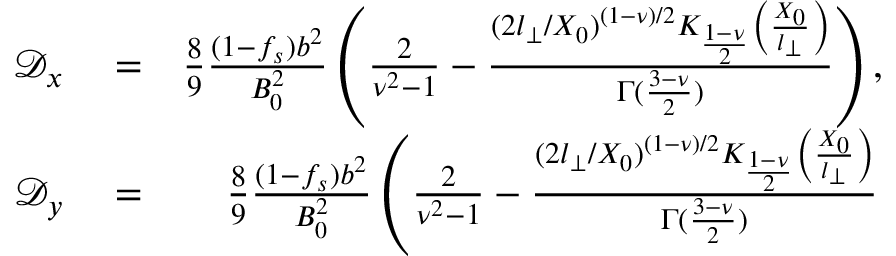<formula> <loc_0><loc_0><loc_500><loc_500>\begin{array} { r l r } { \mathcal { D } _ { x } } & = } & { \frac { 8 } { 9 } \frac { ( 1 - f _ { s } ) b ^ { 2 } } { B _ { 0 } ^ { 2 } } \left ( \frac { 2 } { \nu ^ { 2 } - 1 } - \frac { ( 2 l _ { \perp } / X _ { 0 } ) ^ { ( 1 - \nu ) / 2 } K _ { \frac { 1 - \nu } { 2 } } \left ( \frac { X _ { 0 } } { l _ { \perp } } \right ) } { \Gamma ( \frac { 3 - \nu } { 2 } ) } \right ) , } \\ { \mathcal { D } _ { y } } & = } & { \frac { 8 } { 9 } \frac { ( 1 - f _ { s } ) b ^ { 2 } } { B _ { 0 } ^ { 2 } } \left ( \frac { 2 } { \nu ^ { 2 } - 1 } - \frac { ( 2 l _ { \perp } / X _ { 0 } ) ^ { ( 1 - \nu ) / 2 } K _ { \frac { 1 - \nu } { 2 } } \left ( \frac { X _ { 0 } } { l _ { \perp } } \right ) } { \Gamma ( \frac { 3 - \nu } { 2 } ) } } \end{array}</formula> 